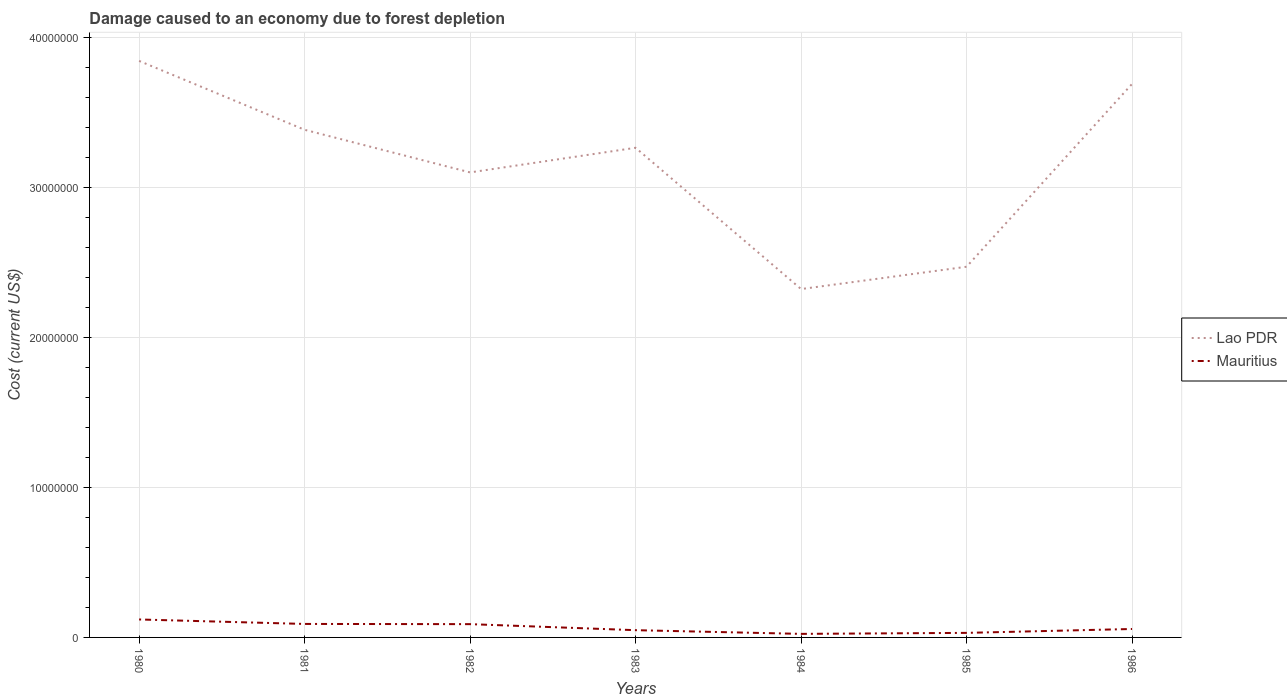Is the number of lines equal to the number of legend labels?
Provide a succinct answer. Yes. Across all years, what is the maximum cost of damage caused due to forest depletion in Mauritius?
Make the answer very short. 2.37e+05. What is the total cost of damage caused due to forest depletion in Lao PDR in the graph?
Give a very brief answer. 1.52e+07. What is the difference between the highest and the second highest cost of damage caused due to forest depletion in Mauritius?
Your answer should be very brief. 9.60e+05. What is the difference between the highest and the lowest cost of damage caused due to forest depletion in Mauritius?
Offer a terse response. 3. Is the cost of damage caused due to forest depletion in Mauritius strictly greater than the cost of damage caused due to forest depletion in Lao PDR over the years?
Provide a succinct answer. Yes. How many lines are there?
Ensure brevity in your answer.  2. How many years are there in the graph?
Ensure brevity in your answer.  7. What is the difference between two consecutive major ticks on the Y-axis?
Ensure brevity in your answer.  1.00e+07. Where does the legend appear in the graph?
Keep it short and to the point. Center right. How are the legend labels stacked?
Provide a succinct answer. Vertical. What is the title of the graph?
Provide a short and direct response. Damage caused to an economy due to forest depletion. Does "Uganda" appear as one of the legend labels in the graph?
Provide a short and direct response. No. What is the label or title of the X-axis?
Make the answer very short. Years. What is the label or title of the Y-axis?
Your answer should be compact. Cost (current US$). What is the Cost (current US$) of Lao PDR in 1980?
Your answer should be compact. 3.84e+07. What is the Cost (current US$) in Mauritius in 1980?
Keep it short and to the point. 1.20e+06. What is the Cost (current US$) in Lao PDR in 1981?
Keep it short and to the point. 3.38e+07. What is the Cost (current US$) of Mauritius in 1981?
Your answer should be compact. 8.99e+05. What is the Cost (current US$) of Lao PDR in 1982?
Your response must be concise. 3.10e+07. What is the Cost (current US$) of Mauritius in 1982?
Offer a very short reply. 8.86e+05. What is the Cost (current US$) in Lao PDR in 1983?
Provide a succinct answer. 3.26e+07. What is the Cost (current US$) of Mauritius in 1983?
Offer a terse response. 4.83e+05. What is the Cost (current US$) in Lao PDR in 1984?
Provide a short and direct response. 2.32e+07. What is the Cost (current US$) in Mauritius in 1984?
Give a very brief answer. 2.37e+05. What is the Cost (current US$) of Lao PDR in 1985?
Your answer should be very brief. 2.47e+07. What is the Cost (current US$) in Mauritius in 1985?
Your answer should be compact. 3.04e+05. What is the Cost (current US$) in Lao PDR in 1986?
Make the answer very short. 3.69e+07. What is the Cost (current US$) in Mauritius in 1986?
Provide a short and direct response. 5.63e+05. Across all years, what is the maximum Cost (current US$) of Lao PDR?
Give a very brief answer. 3.84e+07. Across all years, what is the maximum Cost (current US$) of Mauritius?
Your response must be concise. 1.20e+06. Across all years, what is the minimum Cost (current US$) in Lao PDR?
Your answer should be very brief. 2.32e+07. Across all years, what is the minimum Cost (current US$) of Mauritius?
Keep it short and to the point. 2.37e+05. What is the total Cost (current US$) in Lao PDR in the graph?
Ensure brevity in your answer.  2.21e+08. What is the total Cost (current US$) in Mauritius in the graph?
Keep it short and to the point. 4.57e+06. What is the difference between the Cost (current US$) of Lao PDR in 1980 and that in 1981?
Offer a very short reply. 4.59e+06. What is the difference between the Cost (current US$) in Mauritius in 1980 and that in 1981?
Your response must be concise. 2.98e+05. What is the difference between the Cost (current US$) in Lao PDR in 1980 and that in 1982?
Your answer should be very brief. 7.43e+06. What is the difference between the Cost (current US$) of Mauritius in 1980 and that in 1982?
Provide a short and direct response. 3.11e+05. What is the difference between the Cost (current US$) of Lao PDR in 1980 and that in 1983?
Make the answer very short. 5.79e+06. What is the difference between the Cost (current US$) of Mauritius in 1980 and that in 1983?
Keep it short and to the point. 7.14e+05. What is the difference between the Cost (current US$) in Lao PDR in 1980 and that in 1984?
Provide a succinct answer. 1.52e+07. What is the difference between the Cost (current US$) in Mauritius in 1980 and that in 1984?
Your response must be concise. 9.60e+05. What is the difference between the Cost (current US$) in Lao PDR in 1980 and that in 1985?
Keep it short and to the point. 1.37e+07. What is the difference between the Cost (current US$) in Mauritius in 1980 and that in 1985?
Provide a succinct answer. 8.93e+05. What is the difference between the Cost (current US$) in Lao PDR in 1980 and that in 1986?
Provide a short and direct response. 1.53e+06. What is the difference between the Cost (current US$) of Mauritius in 1980 and that in 1986?
Make the answer very short. 6.34e+05. What is the difference between the Cost (current US$) of Lao PDR in 1981 and that in 1982?
Your response must be concise. 2.84e+06. What is the difference between the Cost (current US$) in Mauritius in 1981 and that in 1982?
Keep it short and to the point. 1.32e+04. What is the difference between the Cost (current US$) of Lao PDR in 1981 and that in 1983?
Provide a short and direct response. 1.20e+06. What is the difference between the Cost (current US$) of Mauritius in 1981 and that in 1983?
Make the answer very short. 4.16e+05. What is the difference between the Cost (current US$) in Lao PDR in 1981 and that in 1984?
Ensure brevity in your answer.  1.06e+07. What is the difference between the Cost (current US$) of Mauritius in 1981 and that in 1984?
Your answer should be compact. 6.62e+05. What is the difference between the Cost (current US$) of Lao PDR in 1981 and that in 1985?
Offer a terse response. 9.13e+06. What is the difference between the Cost (current US$) of Mauritius in 1981 and that in 1985?
Your response must be concise. 5.95e+05. What is the difference between the Cost (current US$) of Lao PDR in 1981 and that in 1986?
Your answer should be compact. -3.06e+06. What is the difference between the Cost (current US$) of Mauritius in 1981 and that in 1986?
Provide a succinct answer. 3.36e+05. What is the difference between the Cost (current US$) in Lao PDR in 1982 and that in 1983?
Keep it short and to the point. -1.64e+06. What is the difference between the Cost (current US$) of Mauritius in 1982 and that in 1983?
Provide a short and direct response. 4.03e+05. What is the difference between the Cost (current US$) in Lao PDR in 1982 and that in 1984?
Your response must be concise. 7.78e+06. What is the difference between the Cost (current US$) of Mauritius in 1982 and that in 1984?
Provide a short and direct response. 6.49e+05. What is the difference between the Cost (current US$) of Lao PDR in 1982 and that in 1985?
Offer a very short reply. 6.29e+06. What is the difference between the Cost (current US$) in Mauritius in 1982 and that in 1985?
Offer a very short reply. 5.82e+05. What is the difference between the Cost (current US$) of Lao PDR in 1982 and that in 1986?
Give a very brief answer. -5.90e+06. What is the difference between the Cost (current US$) in Mauritius in 1982 and that in 1986?
Provide a short and direct response. 3.23e+05. What is the difference between the Cost (current US$) in Lao PDR in 1983 and that in 1984?
Keep it short and to the point. 9.42e+06. What is the difference between the Cost (current US$) of Mauritius in 1983 and that in 1984?
Keep it short and to the point. 2.46e+05. What is the difference between the Cost (current US$) of Lao PDR in 1983 and that in 1985?
Your answer should be compact. 7.93e+06. What is the difference between the Cost (current US$) of Mauritius in 1983 and that in 1985?
Provide a succinct answer. 1.80e+05. What is the difference between the Cost (current US$) in Lao PDR in 1983 and that in 1986?
Ensure brevity in your answer.  -4.26e+06. What is the difference between the Cost (current US$) of Mauritius in 1983 and that in 1986?
Provide a succinct answer. -7.96e+04. What is the difference between the Cost (current US$) of Lao PDR in 1984 and that in 1985?
Ensure brevity in your answer.  -1.49e+06. What is the difference between the Cost (current US$) in Mauritius in 1984 and that in 1985?
Make the answer very short. -6.67e+04. What is the difference between the Cost (current US$) of Lao PDR in 1984 and that in 1986?
Keep it short and to the point. -1.37e+07. What is the difference between the Cost (current US$) of Mauritius in 1984 and that in 1986?
Provide a succinct answer. -3.26e+05. What is the difference between the Cost (current US$) in Lao PDR in 1985 and that in 1986?
Your answer should be compact. -1.22e+07. What is the difference between the Cost (current US$) in Mauritius in 1985 and that in 1986?
Make the answer very short. -2.59e+05. What is the difference between the Cost (current US$) in Lao PDR in 1980 and the Cost (current US$) in Mauritius in 1981?
Offer a terse response. 3.75e+07. What is the difference between the Cost (current US$) in Lao PDR in 1980 and the Cost (current US$) in Mauritius in 1982?
Provide a succinct answer. 3.75e+07. What is the difference between the Cost (current US$) of Lao PDR in 1980 and the Cost (current US$) of Mauritius in 1983?
Provide a succinct answer. 3.80e+07. What is the difference between the Cost (current US$) in Lao PDR in 1980 and the Cost (current US$) in Mauritius in 1984?
Your answer should be compact. 3.82e+07. What is the difference between the Cost (current US$) in Lao PDR in 1980 and the Cost (current US$) in Mauritius in 1985?
Ensure brevity in your answer.  3.81e+07. What is the difference between the Cost (current US$) in Lao PDR in 1980 and the Cost (current US$) in Mauritius in 1986?
Provide a short and direct response. 3.79e+07. What is the difference between the Cost (current US$) in Lao PDR in 1981 and the Cost (current US$) in Mauritius in 1982?
Provide a succinct answer. 3.30e+07. What is the difference between the Cost (current US$) of Lao PDR in 1981 and the Cost (current US$) of Mauritius in 1983?
Give a very brief answer. 3.34e+07. What is the difference between the Cost (current US$) of Lao PDR in 1981 and the Cost (current US$) of Mauritius in 1984?
Keep it short and to the point. 3.36e+07. What is the difference between the Cost (current US$) of Lao PDR in 1981 and the Cost (current US$) of Mauritius in 1985?
Give a very brief answer. 3.35e+07. What is the difference between the Cost (current US$) of Lao PDR in 1981 and the Cost (current US$) of Mauritius in 1986?
Provide a succinct answer. 3.33e+07. What is the difference between the Cost (current US$) in Lao PDR in 1982 and the Cost (current US$) in Mauritius in 1983?
Make the answer very short. 3.05e+07. What is the difference between the Cost (current US$) in Lao PDR in 1982 and the Cost (current US$) in Mauritius in 1984?
Ensure brevity in your answer.  3.08e+07. What is the difference between the Cost (current US$) in Lao PDR in 1982 and the Cost (current US$) in Mauritius in 1985?
Your answer should be compact. 3.07e+07. What is the difference between the Cost (current US$) of Lao PDR in 1982 and the Cost (current US$) of Mauritius in 1986?
Provide a short and direct response. 3.04e+07. What is the difference between the Cost (current US$) of Lao PDR in 1983 and the Cost (current US$) of Mauritius in 1984?
Make the answer very short. 3.24e+07. What is the difference between the Cost (current US$) in Lao PDR in 1983 and the Cost (current US$) in Mauritius in 1985?
Your answer should be compact. 3.23e+07. What is the difference between the Cost (current US$) of Lao PDR in 1983 and the Cost (current US$) of Mauritius in 1986?
Keep it short and to the point. 3.21e+07. What is the difference between the Cost (current US$) in Lao PDR in 1984 and the Cost (current US$) in Mauritius in 1985?
Provide a succinct answer. 2.29e+07. What is the difference between the Cost (current US$) of Lao PDR in 1984 and the Cost (current US$) of Mauritius in 1986?
Give a very brief answer. 2.27e+07. What is the difference between the Cost (current US$) in Lao PDR in 1985 and the Cost (current US$) in Mauritius in 1986?
Offer a terse response. 2.41e+07. What is the average Cost (current US$) of Lao PDR per year?
Keep it short and to the point. 3.15e+07. What is the average Cost (current US$) in Mauritius per year?
Offer a very short reply. 6.53e+05. In the year 1980, what is the difference between the Cost (current US$) of Lao PDR and Cost (current US$) of Mauritius?
Your response must be concise. 3.72e+07. In the year 1981, what is the difference between the Cost (current US$) in Lao PDR and Cost (current US$) in Mauritius?
Give a very brief answer. 3.29e+07. In the year 1982, what is the difference between the Cost (current US$) in Lao PDR and Cost (current US$) in Mauritius?
Your answer should be very brief. 3.01e+07. In the year 1983, what is the difference between the Cost (current US$) of Lao PDR and Cost (current US$) of Mauritius?
Provide a short and direct response. 3.22e+07. In the year 1984, what is the difference between the Cost (current US$) in Lao PDR and Cost (current US$) in Mauritius?
Offer a very short reply. 2.30e+07. In the year 1985, what is the difference between the Cost (current US$) of Lao PDR and Cost (current US$) of Mauritius?
Your response must be concise. 2.44e+07. In the year 1986, what is the difference between the Cost (current US$) in Lao PDR and Cost (current US$) in Mauritius?
Make the answer very short. 3.63e+07. What is the ratio of the Cost (current US$) in Lao PDR in 1980 to that in 1981?
Ensure brevity in your answer.  1.14. What is the ratio of the Cost (current US$) in Mauritius in 1980 to that in 1981?
Your response must be concise. 1.33. What is the ratio of the Cost (current US$) of Lao PDR in 1980 to that in 1982?
Give a very brief answer. 1.24. What is the ratio of the Cost (current US$) of Mauritius in 1980 to that in 1982?
Your response must be concise. 1.35. What is the ratio of the Cost (current US$) of Lao PDR in 1980 to that in 1983?
Provide a succinct answer. 1.18. What is the ratio of the Cost (current US$) in Mauritius in 1980 to that in 1983?
Your response must be concise. 2.48. What is the ratio of the Cost (current US$) of Lao PDR in 1980 to that in 1984?
Your response must be concise. 1.65. What is the ratio of the Cost (current US$) of Mauritius in 1980 to that in 1984?
Offer a terse response. 5.05. What is the ratio of the Cost (current US$) of Lao PDR in 1980 to that in 1985?
Offer a very short reply. 1.56. What is the ratio of the Cost (current US$) of Mauritius in 1980 to that in 1985?
Offer a terse response. 3.94. What is the ratio of the Cost (current US$) of Lao PDR in 1980 to that in 1986?
Your answer should be very brief. 1.04. What is the ratio of the Cost (current US$) in Mauritius in 1980 to that in 1986?
Ensure brevity in your answer.  2.13. What is the ratio of the Cost (current US$) in Lao PDR in 1981 to that in 1982?
Your answer should be compact. 1.09. What is the ratio of the Cost (current US$) of Mauritius in 1981 to that in 1982?
Your answer should be very brief. 1.01. What is the ratio of the Cost (current US$) of Lao PDR in 1981 to that in 1983?
Your answer should be compact. 1.04. What is the ratio of the Cost (current US$) in Mauritius in 1981 to that in 1983?
Make the answer very short. 1.86. What is the ratio of the Cost (current US$) of Lao PDR in 1981 to that in 1984?
Provide a succinct answer. 1.46. What is the ratio of the Cost (current US$) in Mauritius in 1981 to that in 1984?
Make the answer very short. 3.8. What is the ratio of the Cost (current US$) of Lao PDR in 1981 to that in 1985?
Offer a terse response. 1.37. What is the ratio of the Cost (current US$) in Mauritius in 1981 to that in 1985?
Your answer should be compact. 2.96. What is the ratio of the Cost (current US$) of Lao PDR in 1981 to that in 1986?
Ensure brevity in your answer.  0.92. What is the ratio of the Cost (current US$) of Mauritius in 1981 to that in 1986?
Provide a succinct answer. 1.6. What is the ratio of the Cost (current US$) of Lao PDR in 1982 to that in 1983?
Your answer should be very brief. 0.95. What is the ratio of the Cost (current US$) of Mauritius in 1982 to that in 1983?
Provide a succinct answer. 1.83. What is the ratio of the Cost (current US$) of Lao PDR in 1982 to that in 1984?
Provide a succinct answer. 1.33. What is the ratio of the Cost (current US$) in Mauritius in 1982 to that in 1984?
Offer a very short reply. 3.74. What is the ratio of the Cost (current US$) in Lao PDR in 1982 to that in 1985?
Make the answer very short. 1.25. What is the ratio of the Cost (current US$) of Mauritius in 1982 to that in 1985?
Provide a short and direct response. 2.92. What is the ratio of the Cost (current US$) of Lao PDR in 1982 to that in 1986?
Offer a terse response. 0.84. What is the ratio of the Cost (current US$) of Mauritius in 1982 to that in 1986?
Your answer should be compact. 1.57. What is the ratio of the Cost (current US$) of Lao PDR in 1983 to that in 1984?
Offer a very short reply. 1.41. What is the ratio of the Cost (current US$) of Mauritius in 1983 to that in 1984?
Make the answer very short. 2.04. What is the ratio of the Cost (current US$) of Lao PDR in 1983 to that in 1985?
Provide a succinct answer. 1.32. What is the ratio of the Cost (current US$) of Mauritius in 1983 to that in 1985?
Keep it short and to the point. 1.59. What is the ratio of the Cost (current US$) in Lao PDR in 1983 to that in 1986?
Your response must be concise. 0.88. What is the ratio of the Cost (current US$) in Mauritius in 1983 to that in 1986?
Your answer should be very brief. 0.86. What is the ratio of the Cost (current US$) in Lao PDR in 1984 to that in 1985?
Give a very brief answer. 0.94. What is the ratio of the Cost (current US$) in Mauritius in 1984 to that in 1985?
Your response must be concise. 0.78. What is the ratio of the Cost (current US$) of Lao PDR in 1984 to that in 1986?
Give a very brief answer. 0.63. What is the ratio of the Cost (current US$) of Mauritius in 1984 to that in 1986?
Ensure brevity in your answer.  0.42. What is the ratio of the Cost (current US$) in Lao PDR in 1985 to that in 1986?
Provide a succinct answer. 0.67. What is the ratio of the Cost (current US$) of Mauritius in 1985 to that in 1986?
Offer a terse response. 0.54. What is the difference between the highest and the second highest Cost (current US$) in Lao PDR?
Provide a succinct answer. 1.53e+06. What is the difference between the highest and the second highest Cost (current US$) of Mauritius?
Your answer should be very brief. 2.98e+05. What is the difference between the highest and the lowest Cost (current US$) in Lao PDR?
Provide a short and direct response. 1.52e+07. What is the difference between the highest and the lowest Cost (current US$) of Mauritius?
Provide a succinct answer. 9.60e+05. 